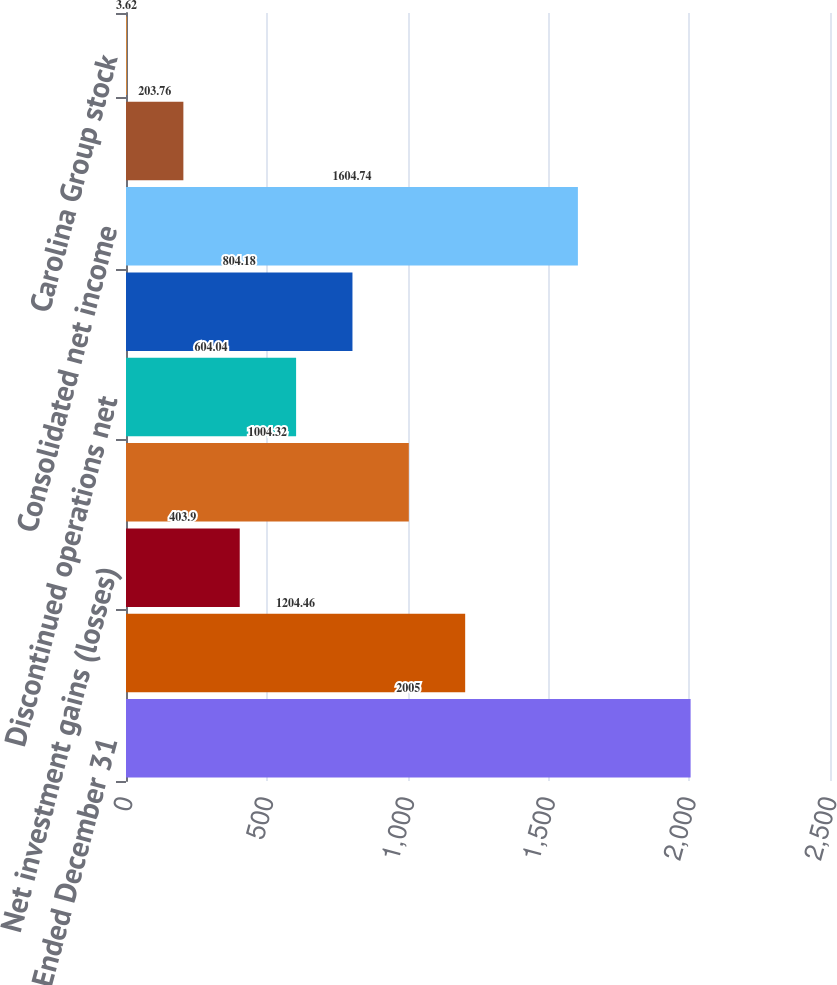<chart> <loc_0><loc_0><loc_500><loc_500><bar_chart><fcel>Year Ended December 31<fcel>Income before net investment<fcel>Net investment gains (losses)<fcel>Income from continuing<fcel>Discontinued operations net<fcel>Net income attributable to<fcel>Consolidated net income<fcel>Loews common stock<fcel>Carolina Group stock<nl><fcel>2005<fcel>1204.46<fcel>403.9<fcel>1004.32<fcel>604.04<fcel>804.18<fcel>1604.74<fcel>203.76<fcel>3.62<nl></chart> 